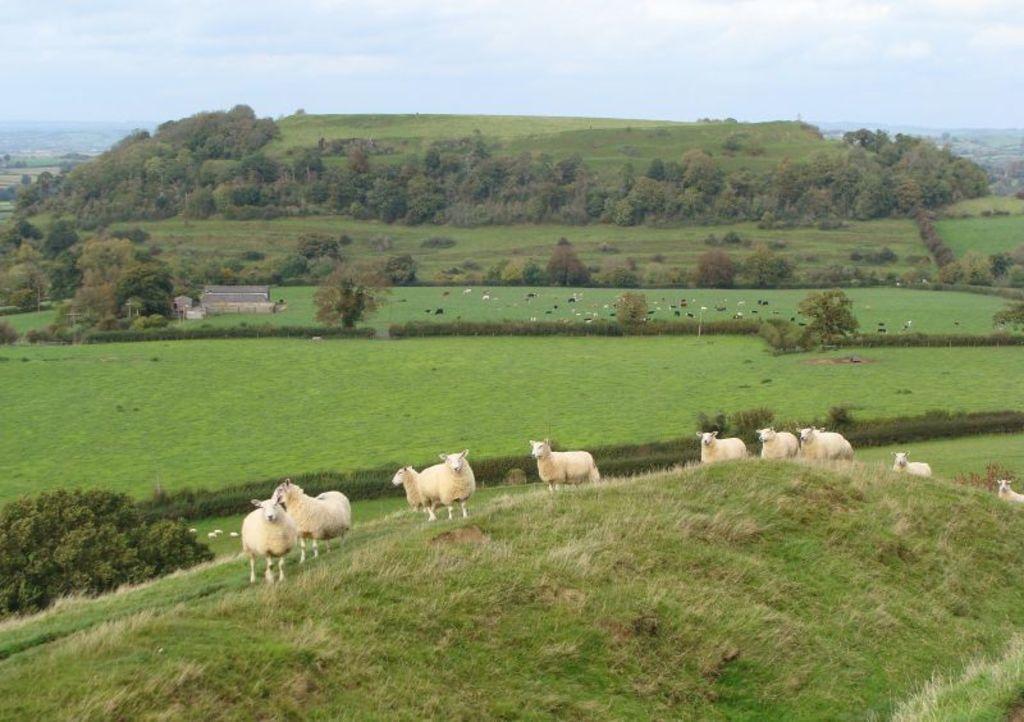Could you give a brief overview of what you see in this image? In this picture we can see some sheep are standing, at the bottom there is grass, in the background we can see trees, there is the sky and clouds at the top of the picture. 